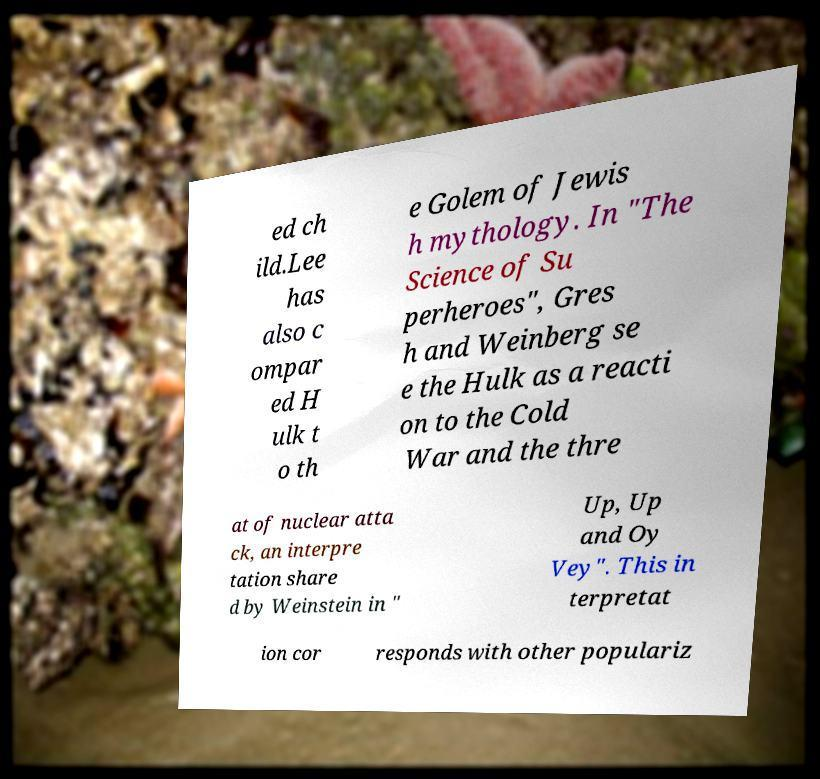Could you extract and type out the text from this image? ed ch ild.Lee has also c ompar ed H ulk t o th e Golem of Jewis h mythology. In "The Science of Su perheroes", Gres h and Weinberg se e the Hulk as a reacti on to the Cold War and the thre at of nuclear atta ck, an interpre tation share d by Weinstein in " Up, Up and Oy Vey". This in terpretat ion cor responds with other populariz 